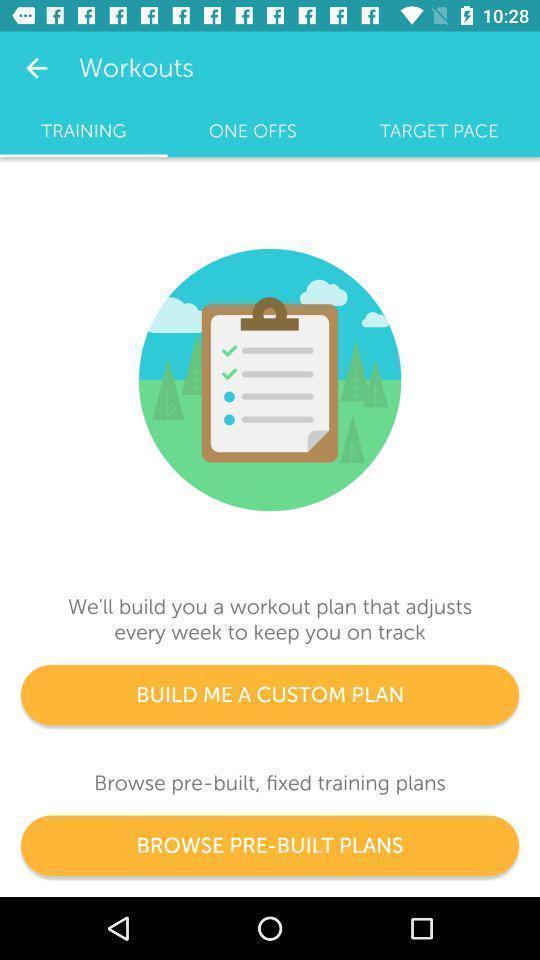Describe the key features of this screenshot. Screen shows different options. 